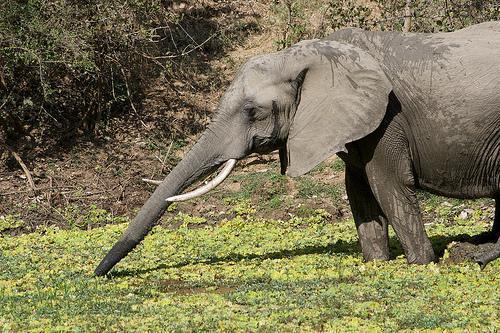How many elephants in picture?
Give a very brief answer. 1. 